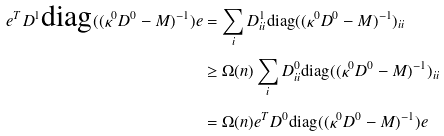Convert formula to latex. <formula><loc_0><loc_0><loc_500><loc_500>e ^ { T } D ^ { 1 } \text {diag} ( ( \kappa ^ { 0 } D ^ { 0 } - M ) ^ { - 1 } ) e & = \sum _ { i } D _ { i i } ^ { 1 } \text {diag} ( ( \kappa ^ { 0 } D ^ { 0 } - M ) ^ { - 1 } ) _ { i i } \\ & \geq \Omega ( n ) \sum _ { i } D _ { i i } ^ { 0 } \text {diag} ( ( \kappa ^ { 0 } D ^ { 0 } - M ) ^ { - 1 } ) _ { i i } \\ & = \Omega ( n ) e ^ { T } D ^ { 0 } \text {diag} ( ( \kappa ^ { 0 } D ^ { 0 } - M ) ^ { - 1 } ) e</formula> 